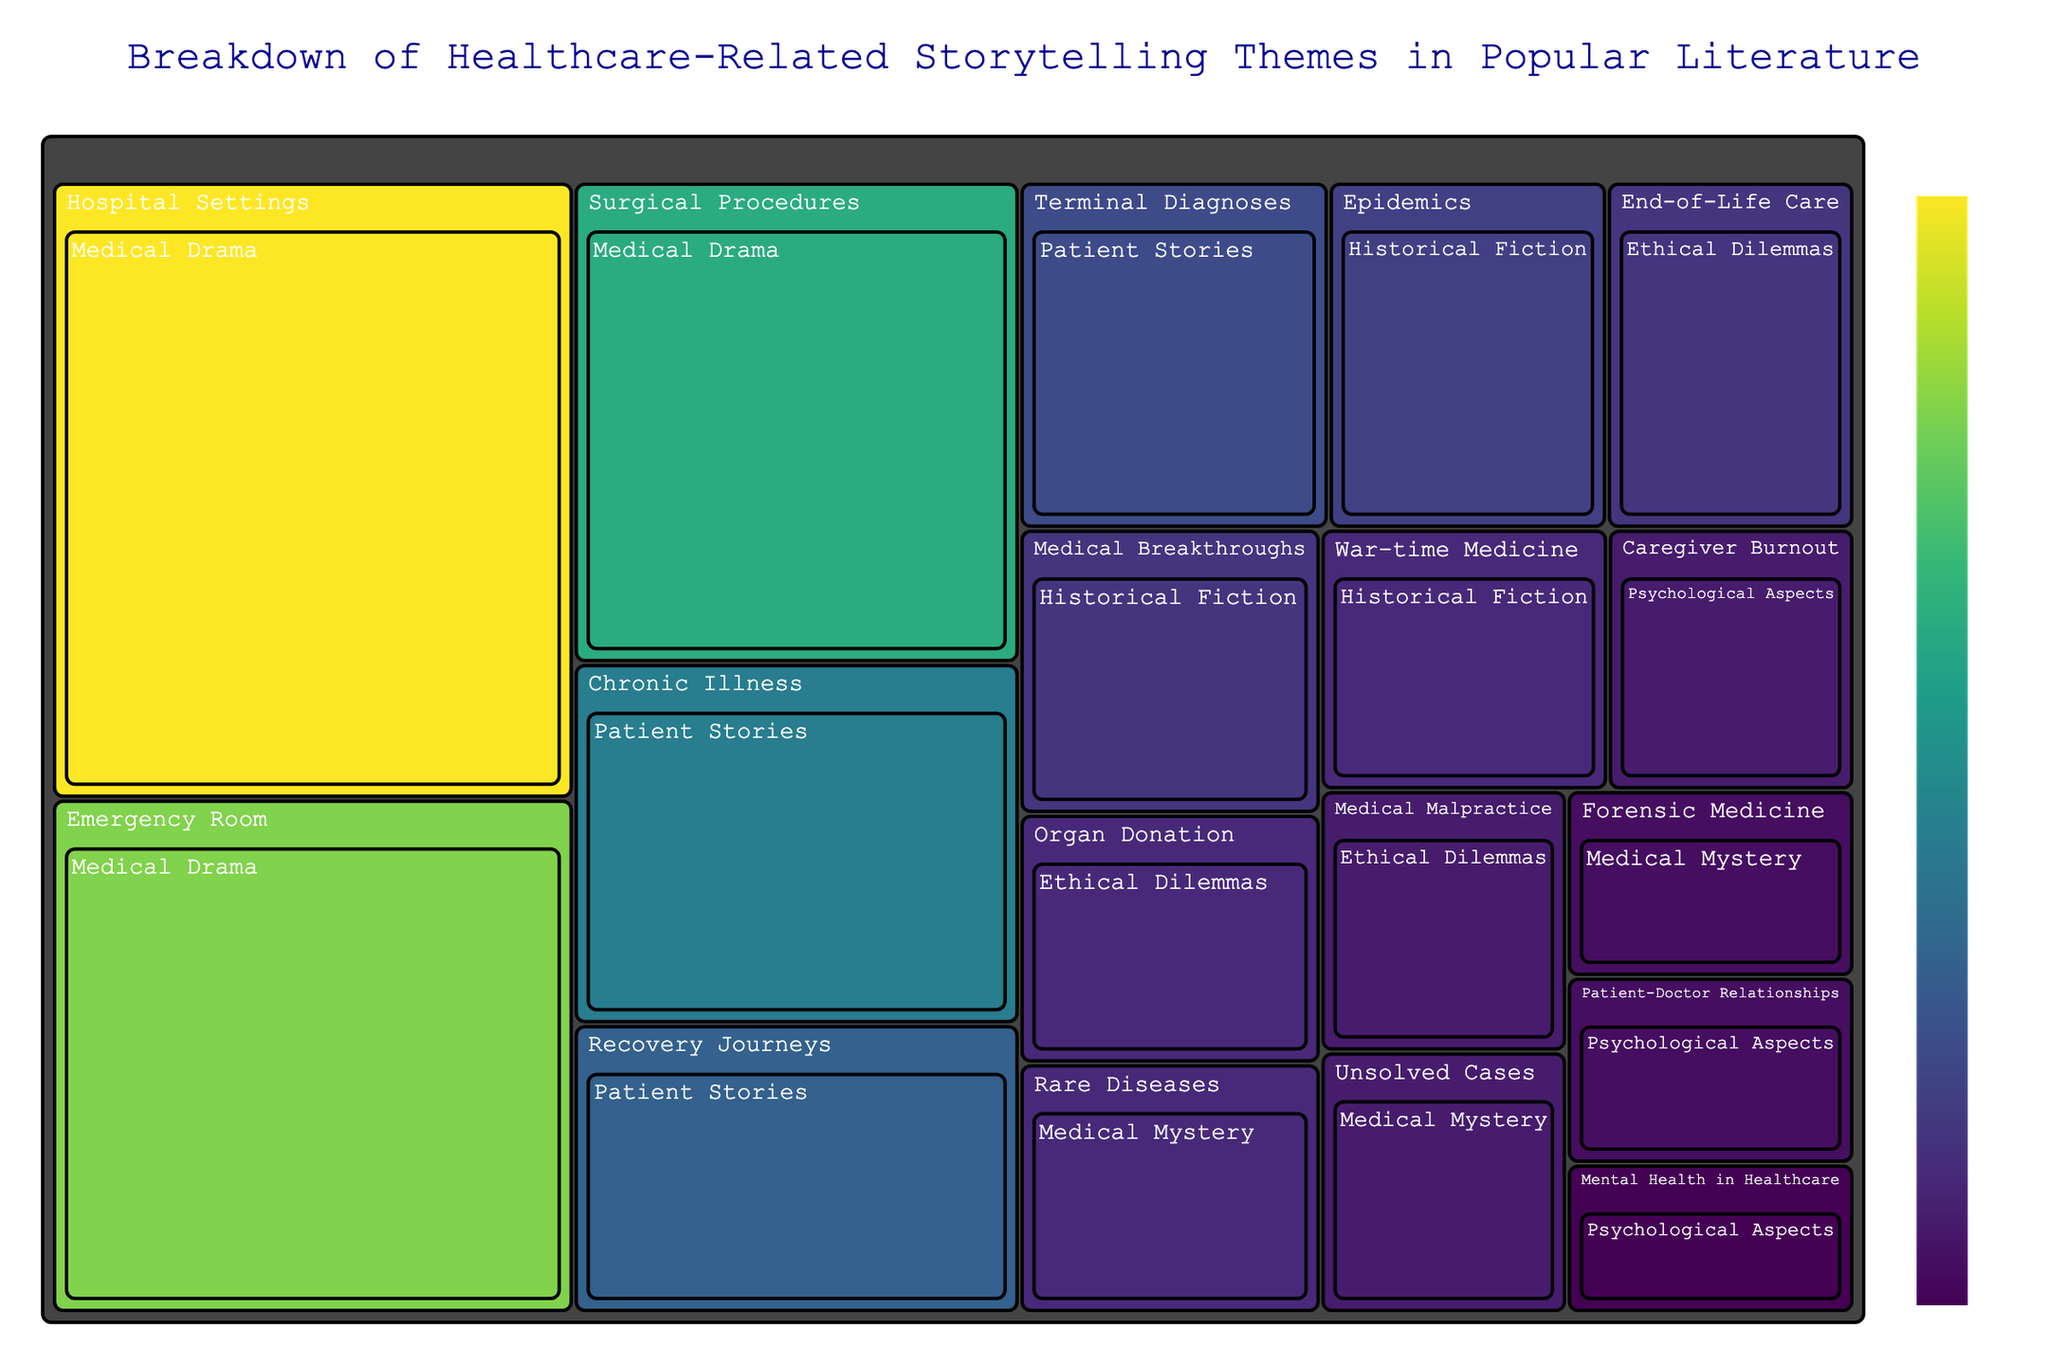What are the three healthcare storytelling themes with the highest values? The figure shows the value associated with each theme. The themes "Hospital Settings," "Emergency Room," and "Surgical Procedures" under "Medical Drama" have the highest values.
Answer: Hospital Settings, Emergency Room, Surgical Procedures Which theme in "Patient Stories" has the lowest value? Refer to the "Patient Stories" section in the treemap and compare the values. The theme "Terminal Diagnoses" has the lowest value within this category.
Answer: Terminal Diagnoses How many storytelling themes are there related to "Ethical Dilemmas"? Count all themes listed under the "Ethical Dilemmas" category in the treemap. There are three themes: "End-of-Life Care," "Organ Donation," and "Medical Malpractice."
Answer: 3 What is the combined value of all themes under "Psychological Aspects"? Sum all the values under "Psychological Aspects": Caregiver Burnout (6), Patient-Doctor Relationships (5), and Mental Health in Healthcare (4). The total is 6 + 5 + 4.
Answer: 15 Which theme has a higher value, "Epidemics" or "War-time Medicine"? Compare the values listed for "Epidemics" (9) and "War-time Medicine" (7) in the "Historical Fiction" category. "Epidemics" has a higher value.
Answer: Epidemics What is the total number of categories represented in the treemap? The categories are the top-level divisions in the treemap. These are: "Medical Drama," "Patient Stories," "Ethical Dilemmas," "Historical Fiction," "Psychological Aspects," and "Medical Mystery." Count these.
Answer: 6 Between "Medical Drama" themes "Surgical Procedures" and "Emergency Room," which one has a higher value and by how much? Compare the values for "Surgical Procedures" (20) and "Emergency Room" (25) in the "Medical Drama" category. "Emergency Room" has a higher value by 25 - 20.
Answer: Emergency Room, 5 Which category has themes with the smallest individual values, and what are those values? Look for the smallest values in different categories. The "Psychological Aspects" category has the smallest individual values: Caregiver Burnout (6), Patient-Doctor Relationships (5), Mental Health in Healthcare (4).
Answer: Psychological Aspects, 6, 5, 4 What is the difference in value between "Organ Donation" and "Forensic Medicine"? Compare the values for "Organ Donation" (7) in "Ethical Dilemmas" and "Forensic Medicine" (5) in "Medical Mystery". The difference is 7 - 5.
Answer: 2 